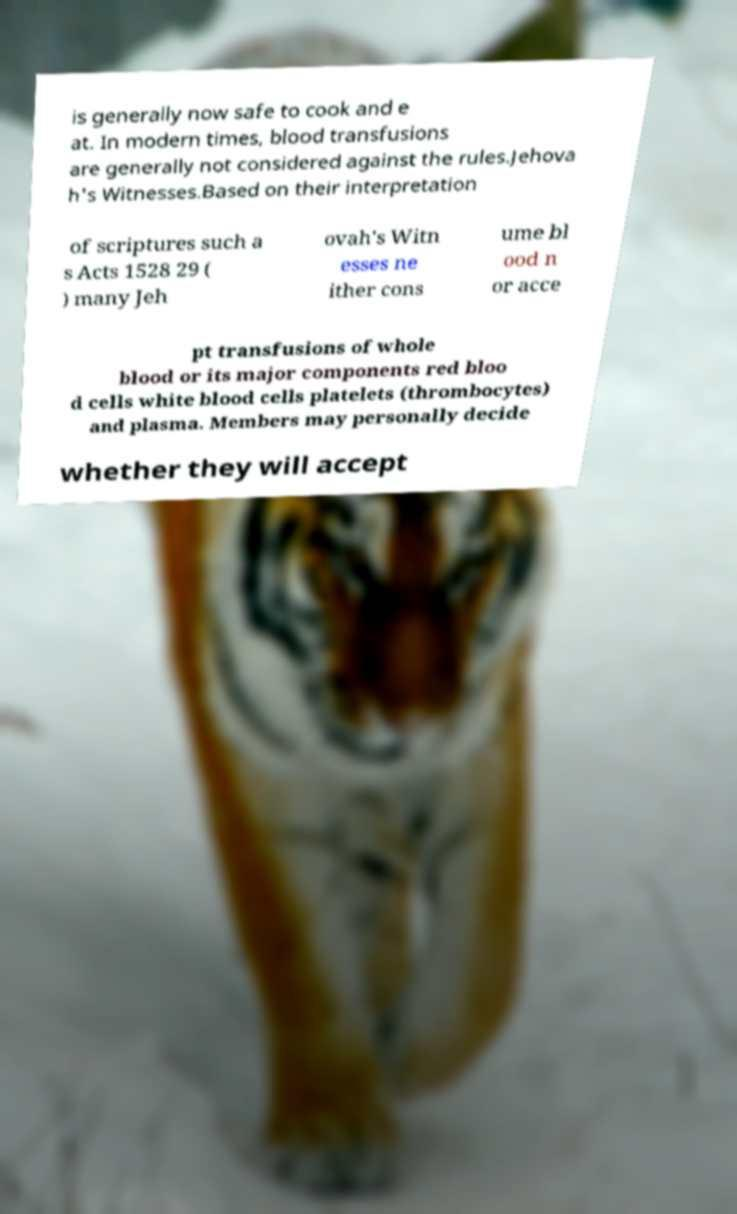What messages or text are displayed in this image? I need them in a readable, typed format. is generally now safe to cook and e at. In modern times, blood transfusions are generally not considered against the rules.Jehova h's Witnesses.Based on their interpretation of scriptures such a s Acts 1528 29 ( ) many Jeh ovah's Witn esses ne ither cons ume bl ood n or acce pt transfusions of whole blood or its major components red bloo d cells white blood cells platelets (thrombocytes) and plasma. Members may personally decide whether they will accept 